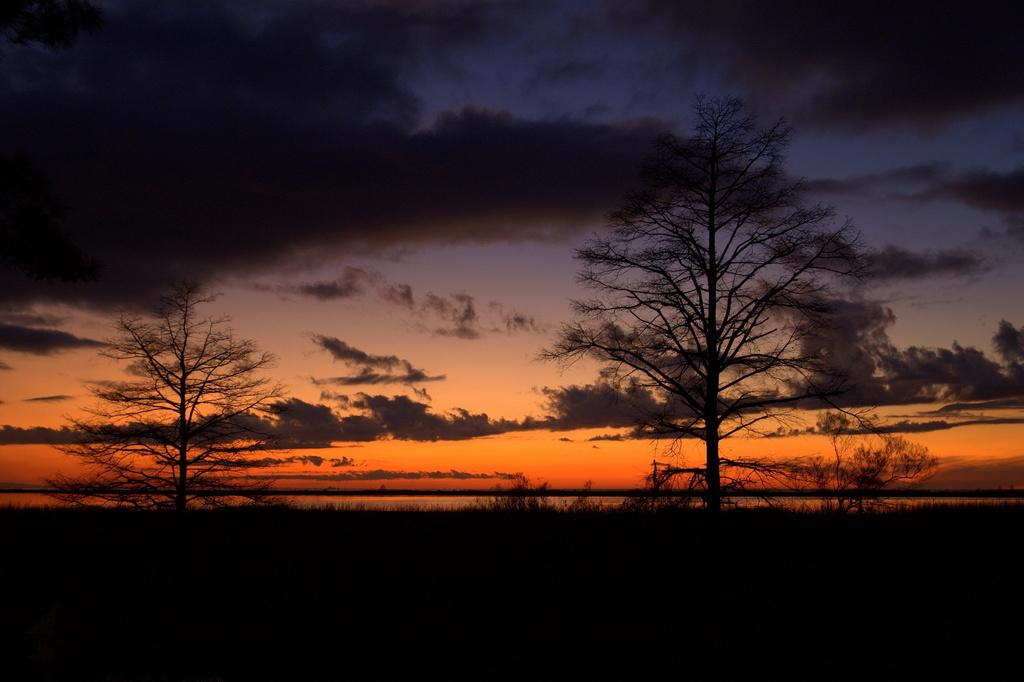What type of vegetation can be seen in the image? There are trees in the image. What natural element is visible in the image besides the trees? There is water visible in the image. What part of the sky is visible in the image? The sky is visible in the image. What can be observed in the sky in the image? Clouds are present in the sky. What type of fold can be seen in the history of the bridge in the image? There is no bridge or history of a bridge present in the image. 